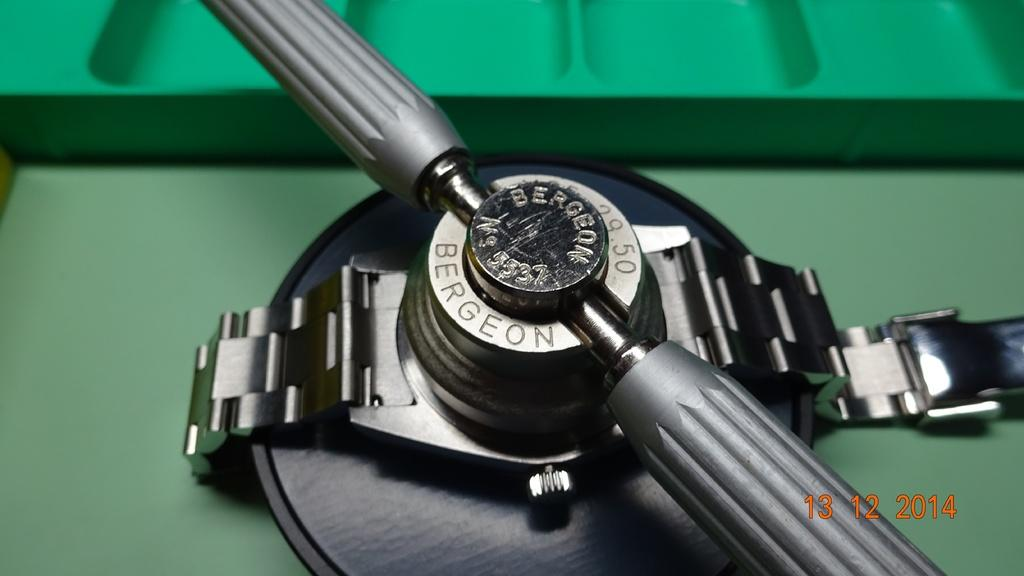<image>
Offer a succinct explanation of the picture presented. A Bergeon watch is being worked on in 2014 